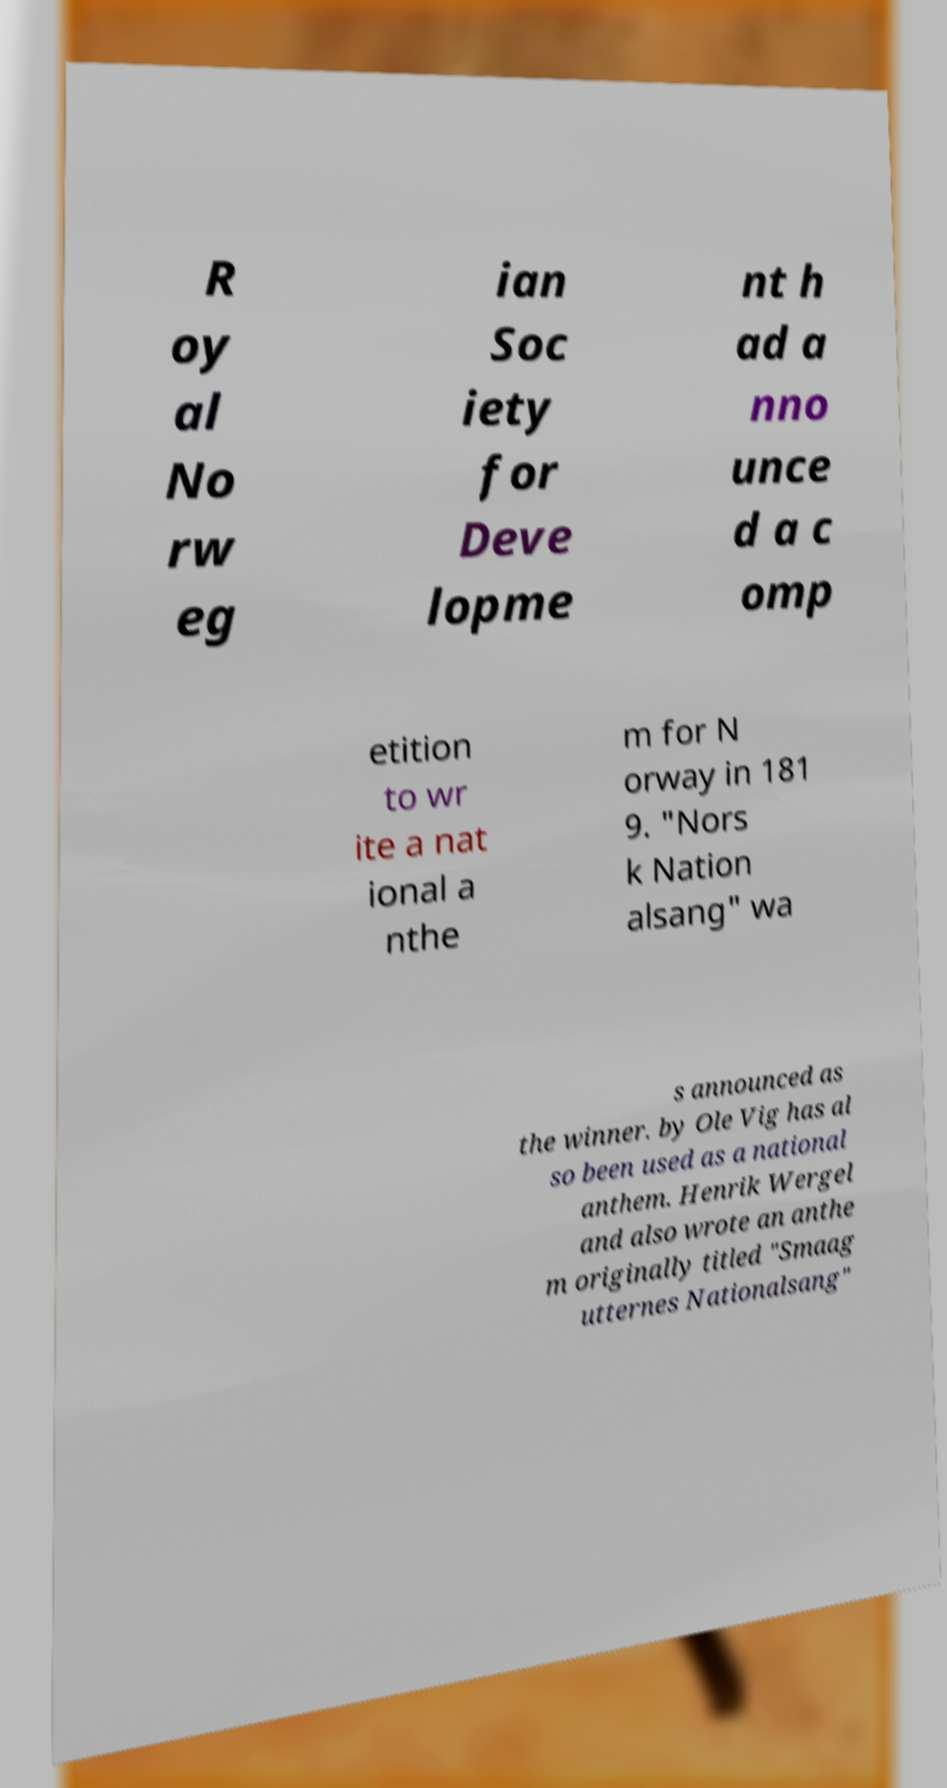What messages or text are displayed in this image? I need them in a readable, typed format. R oy al No rw eg ian Soc iety for Deve lopme nt h ad a nno unce d a c omp etition to wr ite a nat ional a nthe m for N orway in 181 9. "Nors k Nation alsang" wa s announced as the winner. by Ole Vig has al so been used as a national anthem. Henrik Wergel and also wrote an anthe m originally titled "Smaag utternes Nationalsang" 